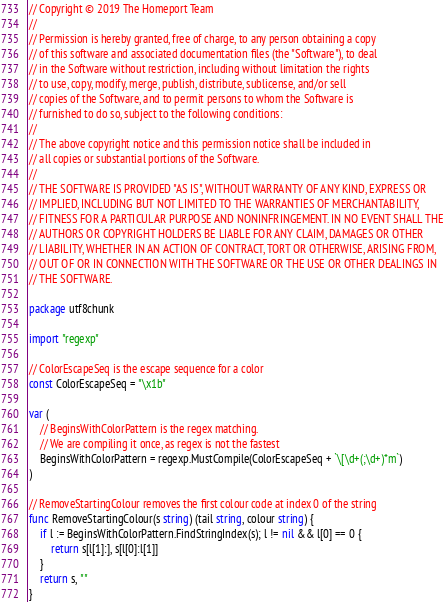<code> <loc_0><loc_0><loc_500><loc_500><_Go_>// Copyright © 2019 The Homeport Team
//
// Permission is hereby granted, free of charge, to any person obtaining a copy
// of this software and associated documentation files (the "Software"), to deal
// in the Software without restriction, including without limitation the rights
// to use, copy, modify, merge, publish, distribute, sublicense, and/or sell
// copies of the Software, and to permit persons to whom the Software is
// furnished to do so, subject to the following conditions:
//
// The above copyright notice and this permission notice shall be included in
// all copies or substantial portions of the Software.
//
// THE SOFTWARE IS PROVIDED "AS IS", WITHOUT WARRANTY OF ANY KIND, EXPRESS OR
// IMPLIED, INCLUDING BUT NOT LIMITED TO THE WARRANTIES OF MERCHANTABILITY,
// FITNESS FOR A PARTICULAR PURPOSE AND NONINFRINGEMENT. IN NO EVENT SHALL THE
// AUTHORS OR COPYRIGHT HOLDERS BE LIABLE FOR ANY CLAIM, DAMAGES OR OTHER
// LIABILITY, WHETHER IN AN ACTION OF CONTRACT, TORT OR OTHERWISE, ARISING FROM,
// OUT OF OR IN CONNECTION WITH THE SOFTWARE OR THE USE OR OTHER DEALINGS IN
// THE SOFTWARE.

package utf8chunk

import "regexp"

// ColorEscapeSeq is the escape sequence for a color
const ColorEscapeSeq = "\x1b"

var (
	// BeginsWithColorPattern is the regex matching.
	// We are compiling it once, as regex is not the fastest
	BeginsWithColorPattern = regexp.MustCompile(ColorEscapeSeq + `\[\d+(;\d+)*m`)
)

// RemoveStartingColour removes the first colour code at index 0 of the string
func RemoveStartingColour(s string) (tail string, colour string) {
	if l := BeginsWithColorPattern.FindStringIndex(s); l != nil && l[0] == 0 {
		return s[l[1]:], s[l[0]:l[1]]
	}
	return s, ""
}
</code> 